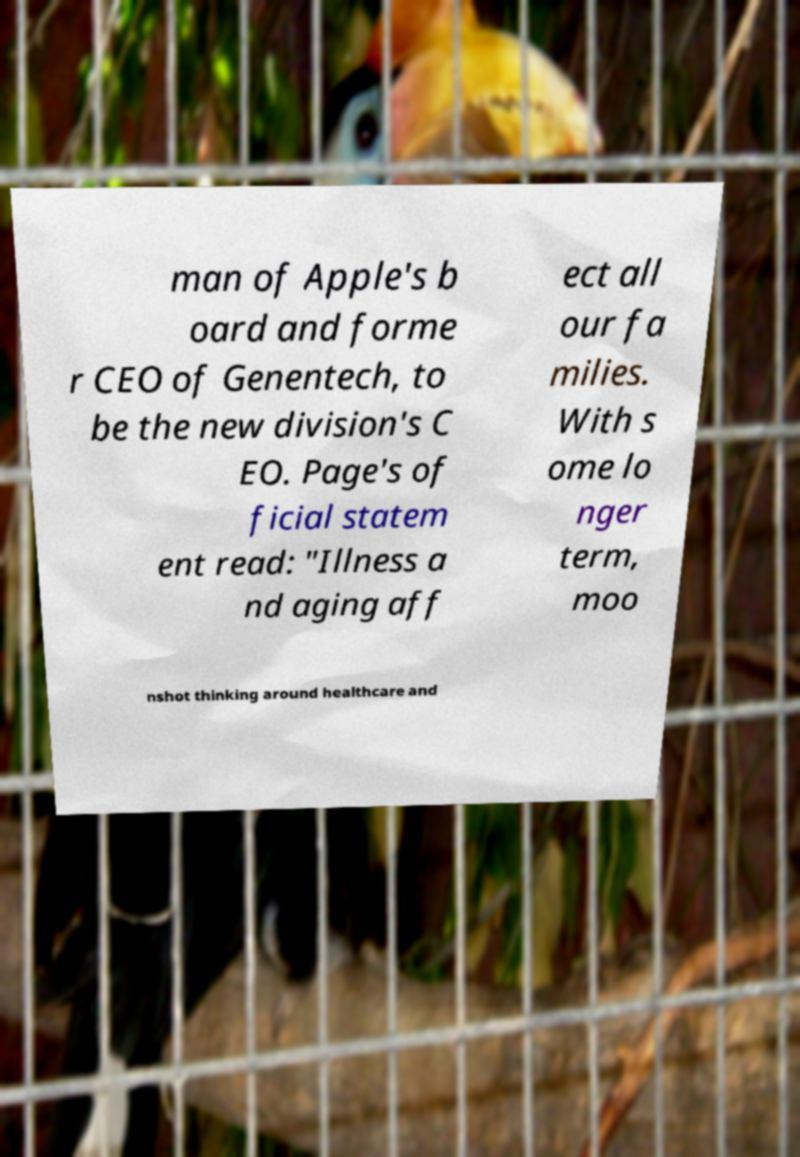Could you assist in decoding the text presented in this image and type it out clearly? man of Apple's b oard and forme r CEO of Genentech, to be the new division's C EO. Page's of ficial statem ent read: "Illness a nd aging aff ect all our fa milies. With s ome lo nger term, moo nshot thinking around healthcare and 